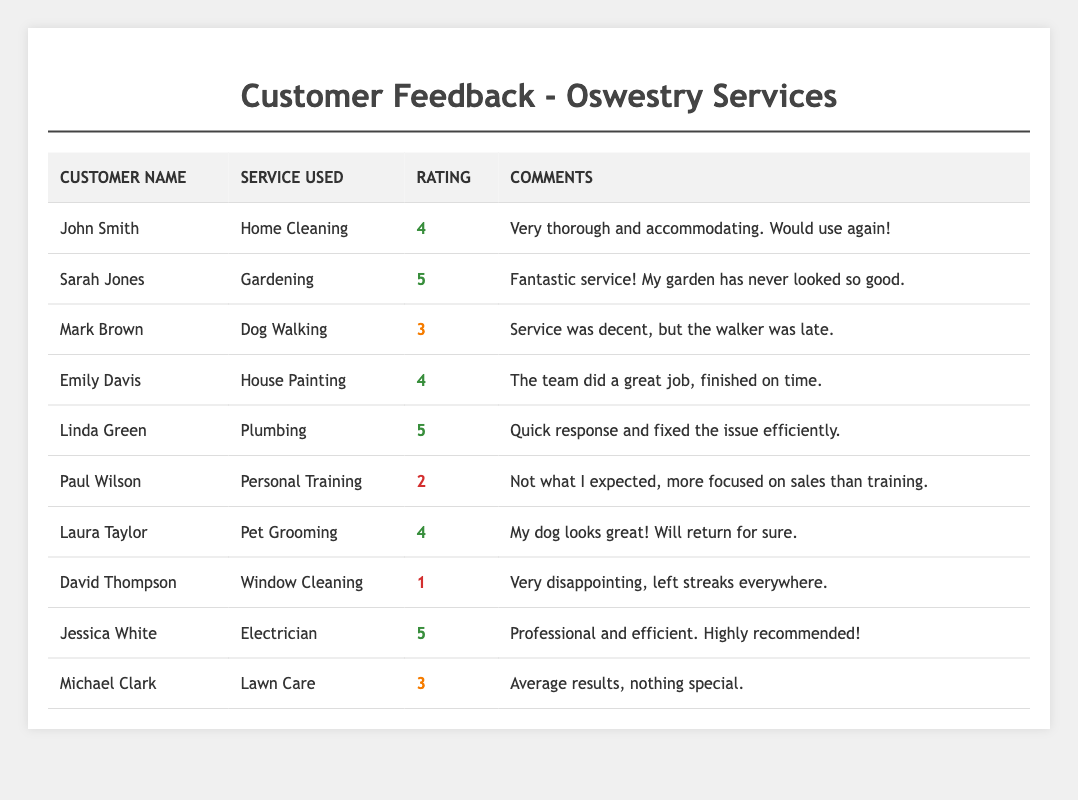What is the highest rating received among the services? The ratings given in the table are 1, 2, 3, 4, and 5. The highest of these is 5, which is received by Sarah Jones for Gardening, Linda Green for Plumbing, and Jessica White for Electrician.
Answer: 5 Which customer provided the lowest rating, and for which service? The lowest rating is 1, provided by David Thompson for Window Cleaning according to the table.
Answer: David Thompson for Window Cleaning What is the average rating across all services? The total ratings are (4 + 5 + 3 + 4 + 5 + 2 + 4 + 1 + 5 + 3) = 36, and there are 10 customers. Thus, the average rating is 36/10 = 3.6.
Answer: 3.6 Are there more customers who rated their service 4 or 5? Counting the occurrences: there are 4 customers who rated it 4 (John Smith, Emily Davis, Laura Taylor, and 4) and 3 who rated it 5 (Sarah Jones, Linda Green, and Jessica White). Therefore, there are more 4 ratings.
Answer: More customers rated 4 How many services received ratings of 3 or lower? There are 3 customers who gave ratings of 3 (Mark Brown, Michael Clark) and 2 customers who rated 2 (Paul Wilson) and 1 (David Thompson), totaling 5 customers.
Answer: 5 customers Which service had the most positive feedback based on comments? The services mentioned with enthusiastic comments include Gardening by Sarah Jones and Electrician by Jessica White. Both received a rating of 5 and positive remarks.
Answer: Gardening and Electrician What percentage of customers rated their service as 4 or higher? There are 7 customers with ratings of 4 or higher (4 rated 4 and 3 rated 5) out of 10 total customers. So, the percentage is (7/10) * 100% = 70%.
Answer: 70% Which service had mixed feedback, based on both rating and comments? Dog Walking received a rating of 3, with a comment stating that while the service was decent, the walker was late. This indicates mixed feedback.
Answer: Dog Walking What is the difference in ratings between the highest and lowest-rated services? The highest rating is 5, and the lowest is 1. Therefore, the difference is 5 - 1 = 4.
Answer: 4 Which service category received the most ratings of 4? The services that received a rating of 4 are Home Cleaning, House Painting, and Pet Grooming, totaling 3 ratings of 4.
Answer: Home Cleaning, House Painting, and Pet Grooming 